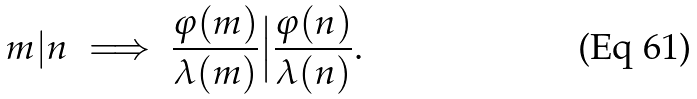Convert formula to latex. <formula><loc_0><loc_0><loc_500><loc_500>m | n \implies \frac { \varphi ( m ) } { \lambda ( m ) } \Big | \frac { \varphi ( n ) } { \lambda ( n ) } .</formula> 